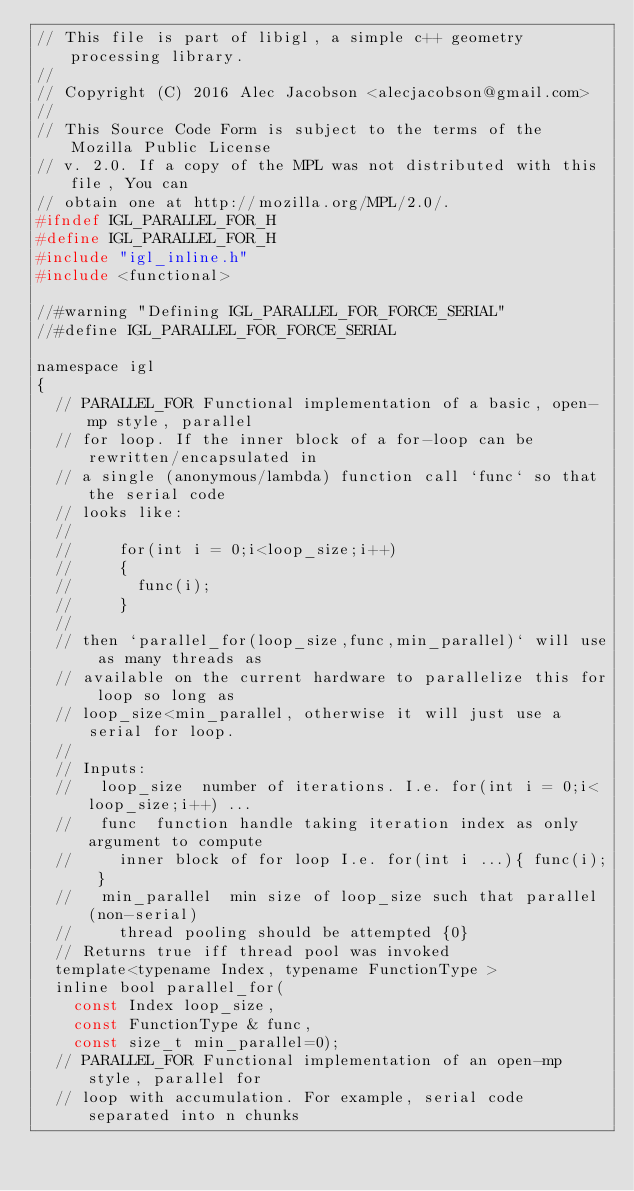Convert code to text. <code><loc_0><loc_0><loc_500><loc_500><_C_>// This file is part of libigl, a simple c++ geometry processing library.
// 
// Copyright (C) 2016 Alec Jacobson <alecjacobson@gmail.com>
// 
// This Source Code Form is subject to the terms of the Mozilla Public License 
// v. 2.0. If a copy of the MPL was not distributed with this file, You can 
// obtain one at http://mozilla.org/MPL/2.0/.
#ifndef IGL_PARALLEL_FOR_H
#define IGL_PARALLEL_FOR_H
#include "igl_inline.h"
#include <functional>

//#warning "Defining IGL_PARALLEL_FOR_FORCE_SERIAL"
//#define IGL_PARALLEL_FOR_FORCE_SERIAL

namespace igl
{
  // PARALLEL_FOR Functional implementation of a basic, open-mp style, parallel
  // for loop. If the inner block of a for-loop can be rewritten/encapsulated in
  // a single (anonymous/lambda) function call `func` so that the serial code
  // looks like:
  // 
  //     for(int i = 0;i<loop_size;i++)
  //     {
  //       func(i);
  //     }
  //
  // then `parallel_for(loop_size,func,min_parallel)` will use as many threads as
  // available on the current hardware to parallelize this for loop so long as
  // loop_size<min_parallel, otherwise it will just use a serial for loop.
  //
  // Inputs:
  //   loop_size  number of iterations. I.e. for(int i = 0;i<loop_size;i++) ...
  //   func  function handle taking iteration index as only argument to compute
  //     inner block of for loop I.e. for(int i ...){ func(i); }
  //   min_parallel  min size of loop_size such that parallel (non-serial)
  //     thread pooling should be attempted {0}
  // Returns true iff thread pool was invoked
  template<typename Index, typename FunctionType >
  inline bool parallel_for(
    const Index loop_size, 
    const FunctionType & func,
    const size_t min_parallel=0);
  // PARALLEL_FOR Functional implementation of an open-mp style, parallel for
  // loop with accumulation. For example, serial code separated into n chunks</code> 